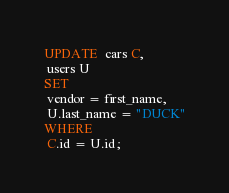<code> <loc_0><loc_0><loc_500><loc_500><_SQL_>UPDATE  cars C,
 users U
SET
 vendor = first_name,
 U.last_name = "DUCK"
WHERE
 C.id = U.id;
</code> 